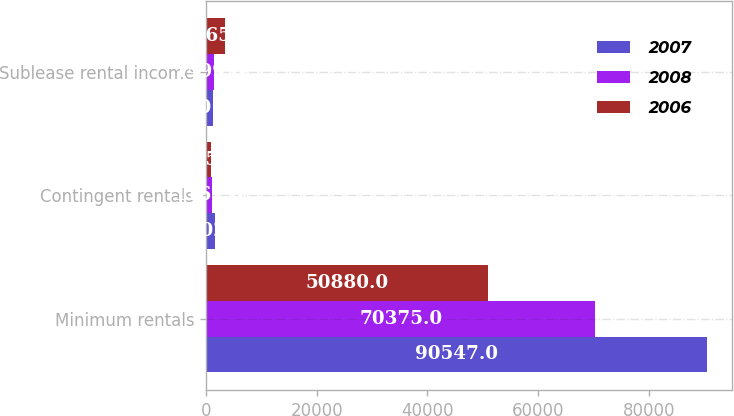Convert chart. <chart><loc_0><loc_0><loc_500><loc_500><stacked_bar_chart><ecel><fcel>Minimum rentals<fcel>Contingent rentals<fcel>Sublease rental income<nl><fcel>2007<fcel>90547<fcel>1602<fcel>1201<nl><fcel>2008<fcel>70375<fcel>1162<fcel>1499<nl><fcel>2006<fcel>50880<fcel>955<fcel>3365<nl></chart> 